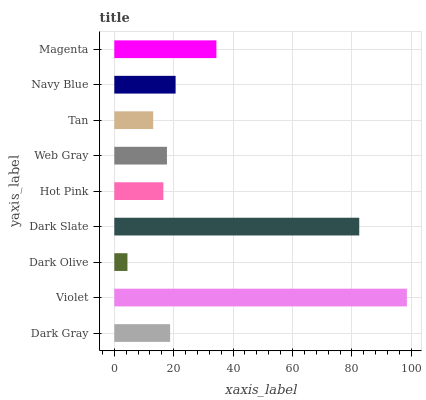Is Dark Olive the minimum?
Answer yes or no. Yes. Is Violet the maximum?
Answer yes or no. Yes. Is Violet the minimum?
Answer yes or no. No. Is Dark Olive the maximum?
Answer yes or no. No. Is Violet greater than Dark Olive?
Answer yes or no. Yes. Is Dark Olive less than Violet?
Answer yes or no. Yes. Is Dark Olive greater than Violet?
Answer yes or no. No. Is Violet less than Dark Olive?
Answer yes or no. No. Is Dark Gray the high median?
Answer yes or no. Yes. Is Dark Gray the low median?
Answer yes or no. Yes. Is Dark Olive the high median?
Answer yes or no. No. Is Dark Olive the low median?
Answer yes or no. No. 